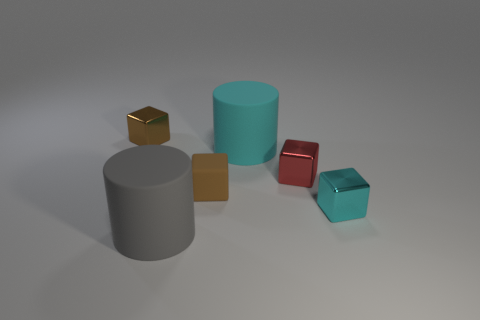Subtract all brown cylinders. How many brown blocks are left? 2 Subtract all tiny cyan metallic cubes. How many cubes are left? 3 Subtract all cyan blocks. How many blocks are left? 3 Subtract 2 cubes. How many cubes are left? 2 Subtract all gray cubes. Subtract all yellow balls. How many cubes are left? 4 Add 4 red blocks. How many objects exist? 10 Subtract all blocks. How many objects are left? 2 Subtract 0 yellow cylinders. How many objects are left? 6 Subtract all small brown rubber blocks. Subtract all small brown objects. How many objects are left? 3 Add 4 brown shiny objects. How many brown shiny objects are left? 5 